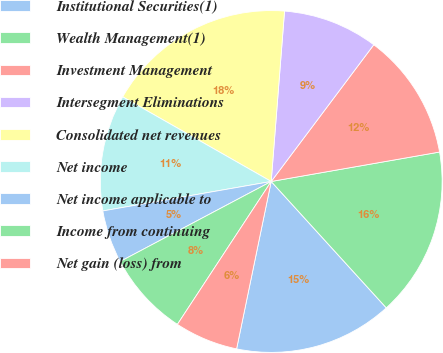Convert chart. <chart><loc_0><loc_0><loc_500><loc_500><pie_chart><fcel>Institutional Securities(1)<fcel>Wealth Management(1)<fcel>Investment Management<fcel>Intersegment Eliminations<fcel>Consolidated net revenues<fcel>Net income<fcel>Net income applicable to<fcel>Income from continuing<fcel>Net gain (loss) from<nl><fcel>15.0%<fcel>16.0%<fcel>12.0%<fcel>9.0%<fcel>18.0%<fcel>11.0%<fcel>5.0%<fcel>8.0%<fcel>6.0%<nl></chart> 